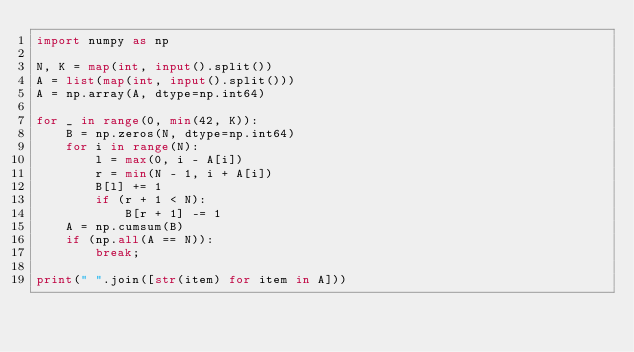<code> <loc_0><loc_0><loc_500><loc_500><_Python_>import numpy as np

N, K = map(int, input().split())
A = list(map(int, input().split()))
A = np.array(A, dtype=np.int64)

for _ in range(0, min(42, K)):
    B = np.zeros(N, dtype=np.int64)
    for i in range(N):
        l = max(0, i - A[i])
        r = min(N - 1, i + A[i])
        B[l] += 1
        if (r + 1 < N):
            B[r + 1] -= 1
    A = np.cumsum(B)
    if (np.all(A == N)):
        break;

print(" ".join([str(item) for item in A]))
</code> 